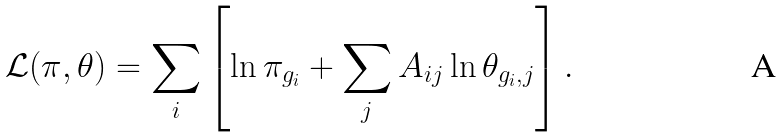Convert formula to latex. <formula><loc_0><loc_0><loc_500><loc_500>\mathcal { L } ( \pi , \theta ) = \sum _ { i } \left [ \ln \pi _ { g _ { i } } + \sum _ { j } A _ { i j } \ln \theta _ { g _ { i } , j } \right ] .</formula> 